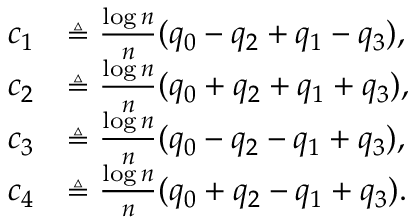Convert formula to latex. <formula><loc_0><loc_0><loc_500><loc_500>\begin{array} { r l } { c _ { 1 } } & { \triangle q \frac { \log n } { n } ( q _ { 0 } - q _ { 2 } + q _ { 1 } - q _ { 3 } ) , } \\ { c _ { 2 } } & { \triangle q \frac { \log n } { n } ( q _ { 0 } + q _ { 2 } + q _ { 1 } + q _ { 3 } ) , } \\ { c _ { 3 } } & { \triangle q \frac { \log n } { n } ( q _ { 0 } - q _ { 2 } - q _ { 1 } + q _ { 3 } ) , } \\ { c _ { 4 } } & { \triangle q \frac { \log n } { n } ( q _ { 0 } + q _ { 2 } - q _ { 1 } + q _ { 3 } ) . } \end{array}</formula> 